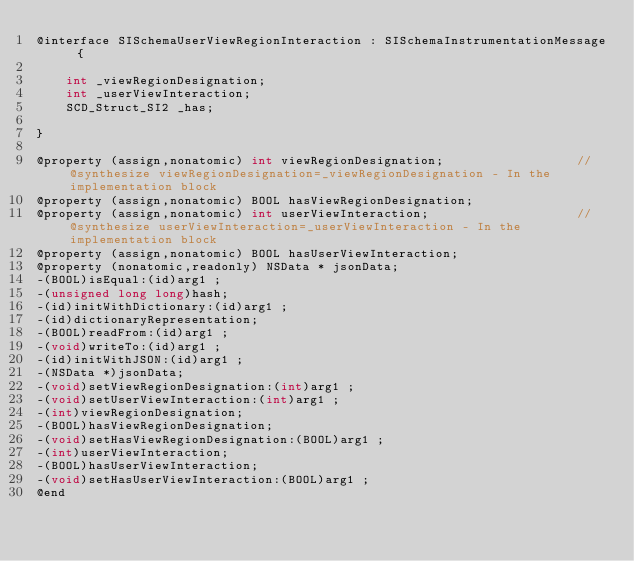Convert code to text. <code><loc_0><loc_0><loc_500><loc_500><_C_>@interface SISchemaUserViewRegionInteraction : SISchemaInstrumentationMessage {

	int _viewRegionDesignation;
	int _userViewInteraction;
	SCD_Struct_SI2 _has;

}

@property (assign,nonatomic) int viewRegionDesignation;                  //@synthesize viewRegionDesignation=_viewRegionDesignation - In the implementation block
@property (assign,nonatomic) BOOL hasViewRegionDesignation; 
@property (assign,nonatomic) int userViewInteraction;                    //@synthesize userViewInteraction=_userViewInteraction - In the implementation block
@property (assign,nonatomic) BOOL hasUserViewInteraction; 
@property (nonatomic,readonly) NSData * jsonData; 
-(BOOL)isEqual:(id)arg1 ;
-(unsigned long long)hash;
-(id)initWithDictionary:(id)arg1 ;
-(id)dictionaryRepresentation;
-(BOOL)readFrom:(id)arg1 ;
-(void)writeTo:(id)arg1 ;
-(id)initWithJSON:(id)arg1 ;
-(NSData *)jsonData;
-(void)setViewRegionDesignation:(int)arg1 ;
-(void)setUserViewInteraction:(int)arg1 ;
-(int)viewRegionDesignation;
-(BOOL)hasViewRegionDesignation;
-(void)setHasViewRegionDesignation:(BOOL)arg1 ;
-(int)userViewInteraction;
-(BOOL)hasUserViewInteraction;
-(void)setHasUserViewInteraction:(BOOL)arg1 ;
@end

</code> 